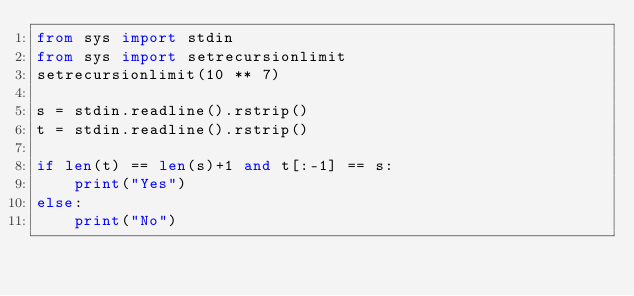Convert code to text. <code><loc_0><loc_0><loc_500><loc_500><_Python_>from sys import stdin
from sys import setrecursionlimit
setrecursionlimit(10 ** 7)

s = stdin.readline().rstrip()
t = stdin.readline().rstrip()

if len(t) == len(s)+1 and t[:-1] == s:
    print("Yes")
else:
    print("No")</code> 